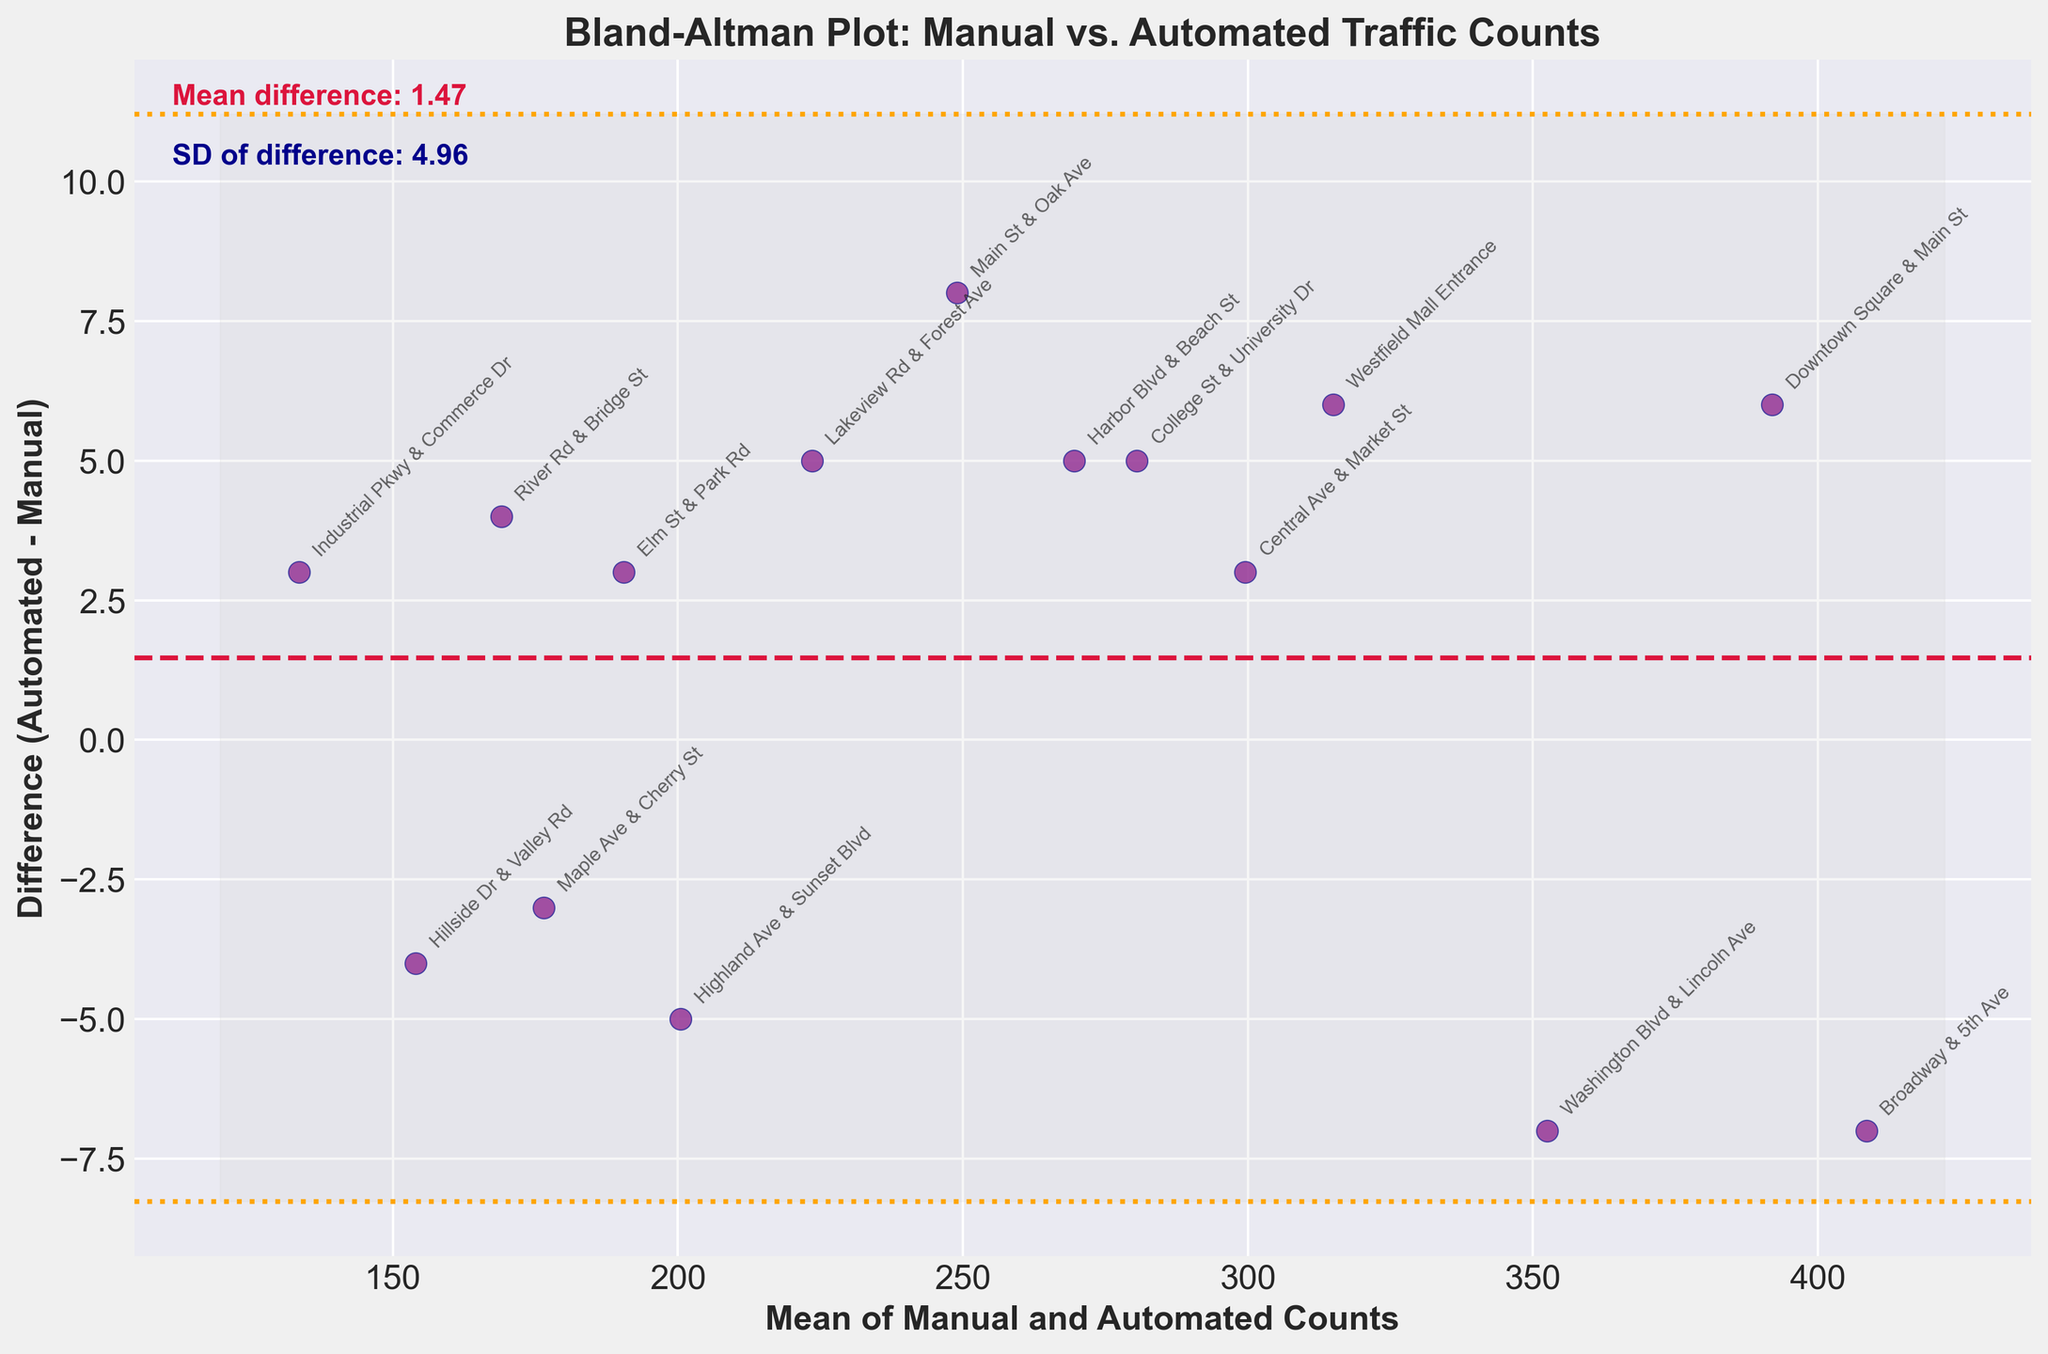What's the title of the figure? The title of the figure is positioned at the top and typically summarizes what the graph represents. By visually scanning the plot, you can see the text displayed prominently.
Answer: Bland-Altman Plot: Manual vs. Automated Traffic Counts How many data points are there in the plot? The number of data points corresponds to the number of intersections for which data is present. Each point is represented on the scatter plot with coordinates indicating the mean and difference values.
Answer: 15 What is the mean difference value indicated by the dashed line? The dashed line in the center of the plot represents the mean difference between automated and manual counts. There's a label next to this line which gives its value.
Answer: ~1.07 What do the dotted lines above and below the mean difference represent? In a Bland-Altman plot, the dotted lines signify the limits of agreement, which are usually calculated as the mean difference ± 1.96 times the standard deviation of the differences. This indicates the range within which most differences between automated and manual counts fall.
Answer: Limits of agreement Which intersection has the highest positive difference between automated and manual counts? Identify the point with the maximum positive vertical distance from the x-axis. Each point is annotated with the intersection name, and River Rd & Bridge St is annotated highest above the line.
Answer: Downtown Square & Main St Which intersection has the lowest negative difference? Find the point closest to the lowest part of the plot. The annotation for the lowest point indicates the intersection with the minimum value.
Answer: Hillside Dr & Valley Rd What is the standard deviation of the differences? The standard deviation is indicated and highlighted in the plot. There's a label that gives the value which helps to understand the distribution of differences between automated and manual counts.
Answer: ~3.77 How many intersections have counts where the automated system under-counted compared to the manual method? To determine if the automated counts are less than the manual counts, look for points below the mean difference line. The number of these points represents the intersections where under-counting occurred.
Answer: 6 